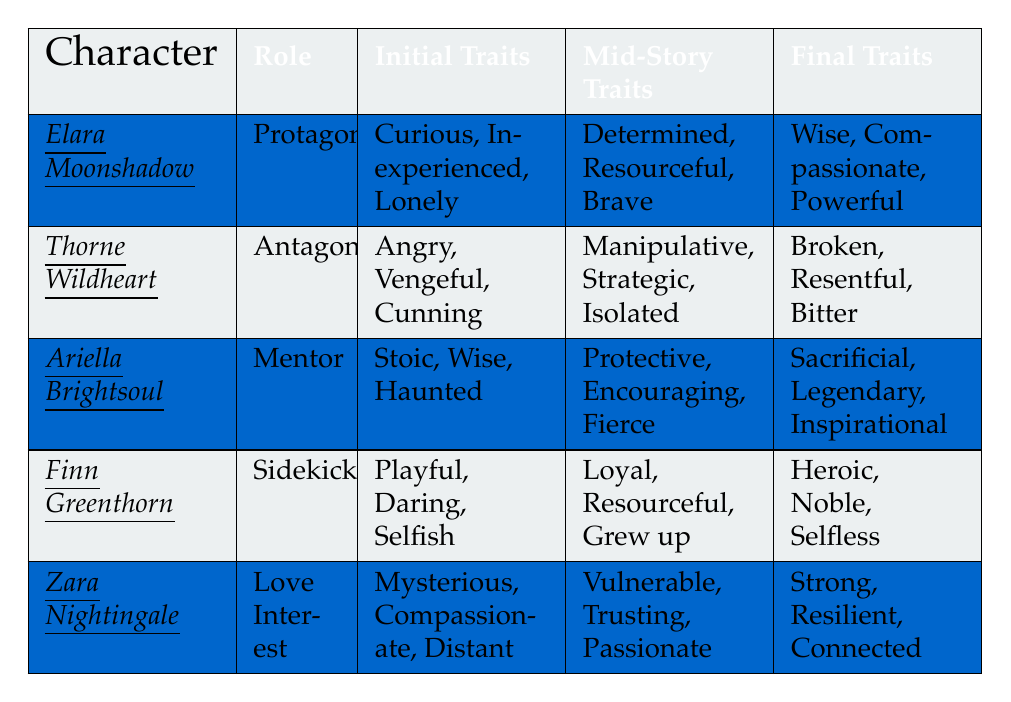What are the initial traits of Elara Moonshadow? The table lists the traits in the "Initial Traits" column for Elara Moonshadow, which are "Curious, Inexperienced, Lonely."
Answer: Curious, Inexperienced, Lonely Which character has the final traits of "Strong, Resilient, Connected"? By checking the "Final Traits" column, we find that Zara Nightingale has these traits.
Answer: Zara Nightingale How many characters are listed in the table? The table contains five characters: Elara Moonshadow, Thorne Wildheart, Ariella Brightsoul, Finn Greenthorn, and Zara Nightingale.
Answer: Five Is Thorne Wildheart the protagonist of the story? The role of Thorne Wildheart is listed as "Antagonist," thus he is not the protagonist.
Answer: No Which character undergoes the most positive change in traits from the initial to final traits? When comparing the characters, Elara Moonshadow shows a shift from "Curious, Inexperienced, Lonely" to "Wise, Compassionate, Powerful," suggesting a significant positive transformation.
Answer: Elara Moonshadow What are the mid-story traits of Ariella Brightsoul? The mid-story traits of Ariella Brightsoul, as shown in the table, are "Protective, Encouraging, Fierce."
Answer: Protective, Encouraging, Fierce Which character had the initial trait of being "Selfish"? Finn Greenthorn exhibits the initial trait of being "Selfish," as indicated in the table.
Answer: Finn Greenthorn Among the characters, who faces their past in a final showdown? Thorne Wildheart confronts his past during the final showdown, as noted in the "Key Events."
Answer: Thorne Wildheart Which character is described as a "wise mentor"? The table designates Ariella Brightsoul as the "Mentor," thus she fits the description of a wise mentor.
Answer: Ariella Brightsoul How does Finn Greenthorn’s character development reflect in his traits? Finn starts as "Playful, Daring, Selfish," and transforms to "Heroic, Noble, Selfless," indicating significant growth in responsibility and selflessness.
Answer: Significant growth What key event leads Zara Nightingale to become a warrior in her own right? The table states that one of Zara's key events is "Becomes a warrior in her own right," suggesting her evolution is a result of her own journey and challenges faced, particularly saving Elara.
Answer: Saves Elara in battle 